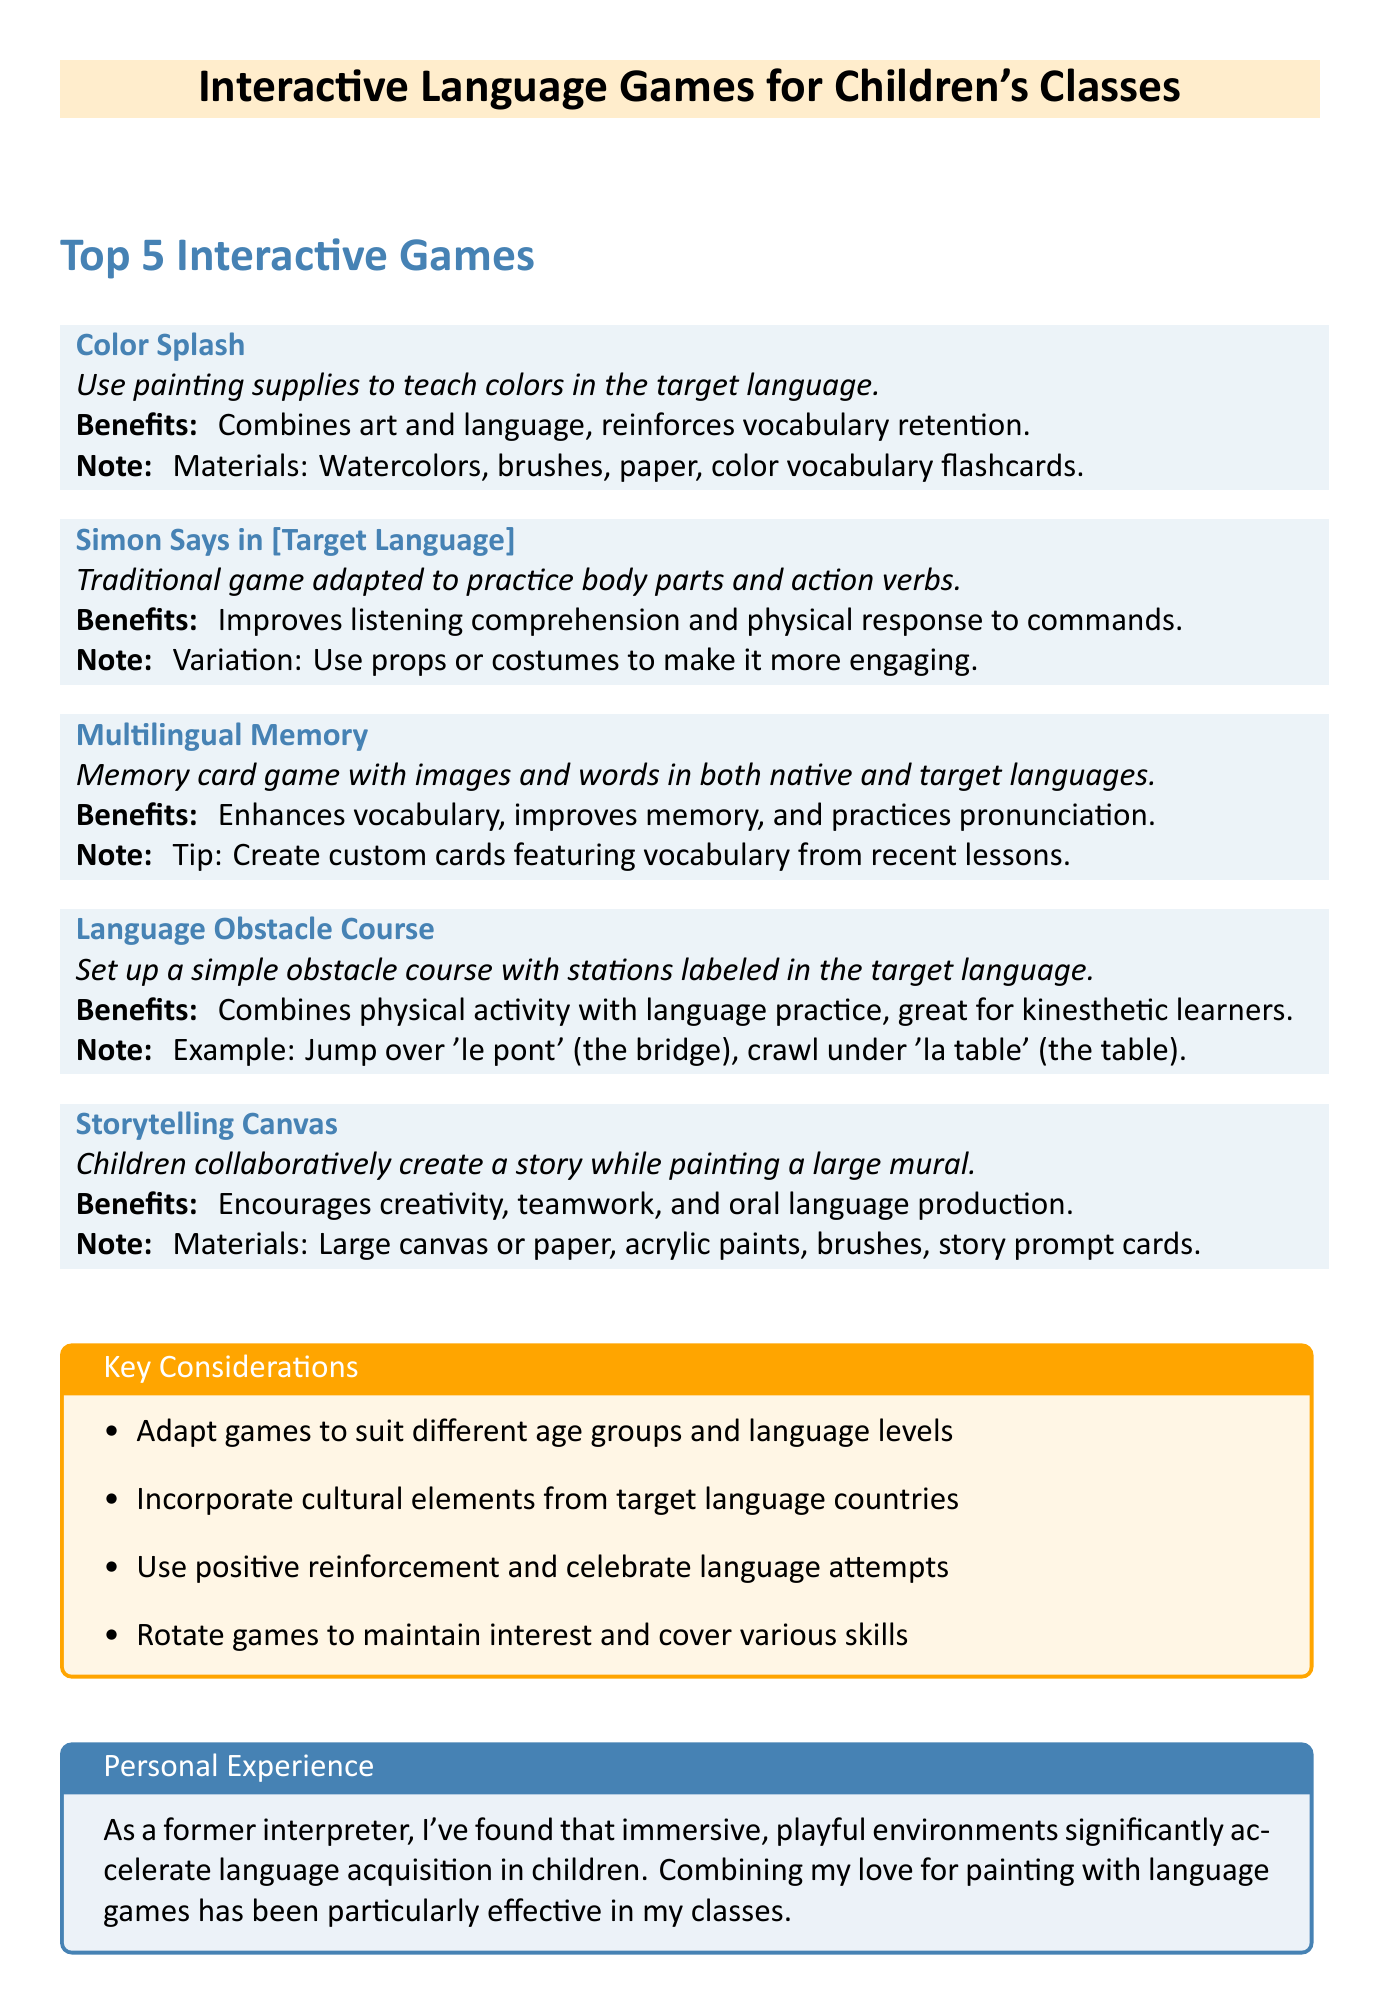What is the name of the first game listed? The first game listed in the document is "Color Splash".
Answer: Color Splash What materials are needed for the "Storytelling Canvas" game? The materials listed for "Storytelling Canvas" are large canvas or paper, acrylic paints, brushes, and story prompt cards.
Answer: Large canvas or paper, acrylic paints, brushes, story prompt cards How many games are described in the document? The document describes a total of five interactive language games.
Answer: Five What is a benefit of playing "Simon Says in [Target Language]"? A benefit of playing "Simon Says in [Target Language]" is that it improves listening comprehension and physical response to commands.
Answer: Improves listening comprehension and physical response to commands What is a key consideration when adapting language games? One key consideration is to adapt games to suit different age groups and language levels.
Answer: Adapt games to suit different age groups and language levels What does the personal experience section highlight? The personal experience section highlights the effectiveness of immersive, playful environments in accelerating language acquisition.
Answer: Effectiveness of immersive, playful environments What type of learners is the "Language Obstacle Course" particularly good for? The "Language Obstacle Course" is particularly good for kinesthetic learners.
Answer: Kinesthetic learners What is the main focus of the games mentioned in the document? The main focus of the games is to combine language learning with interactive play and creativity.
Answer: Combine language learning with interactive play and creativity 